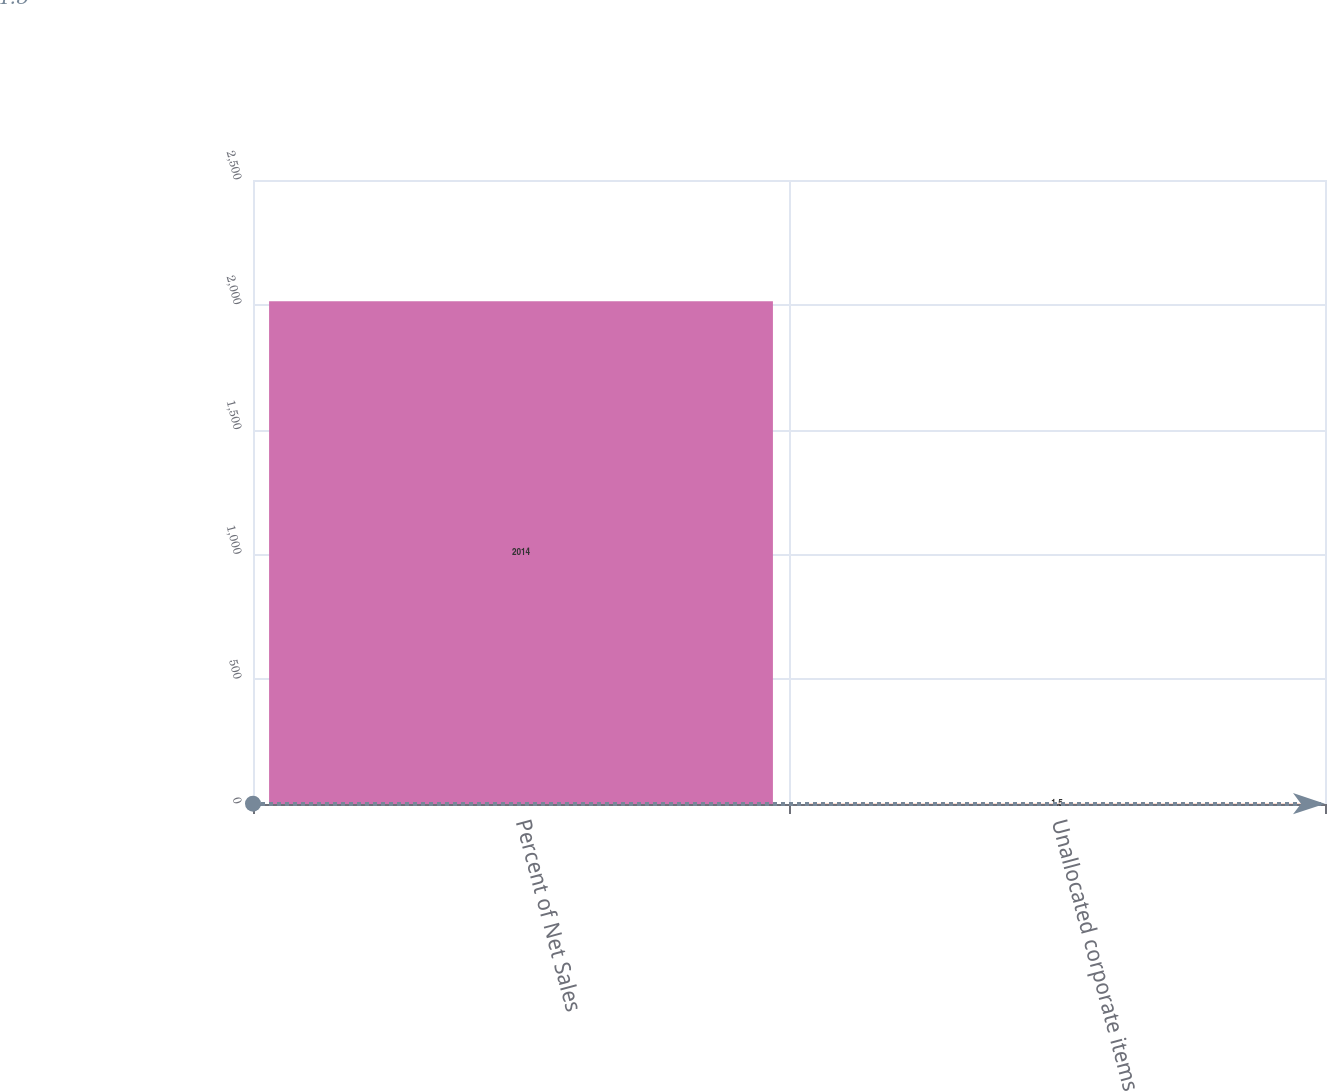<chart> <loc_0><loc_0><loc_500><loc_500><bar_chart><fcel>Percent of Net Sales<fcel>Unallocated corporate items<nl><fcel>2014<fcel>1.5<nl></chart> 